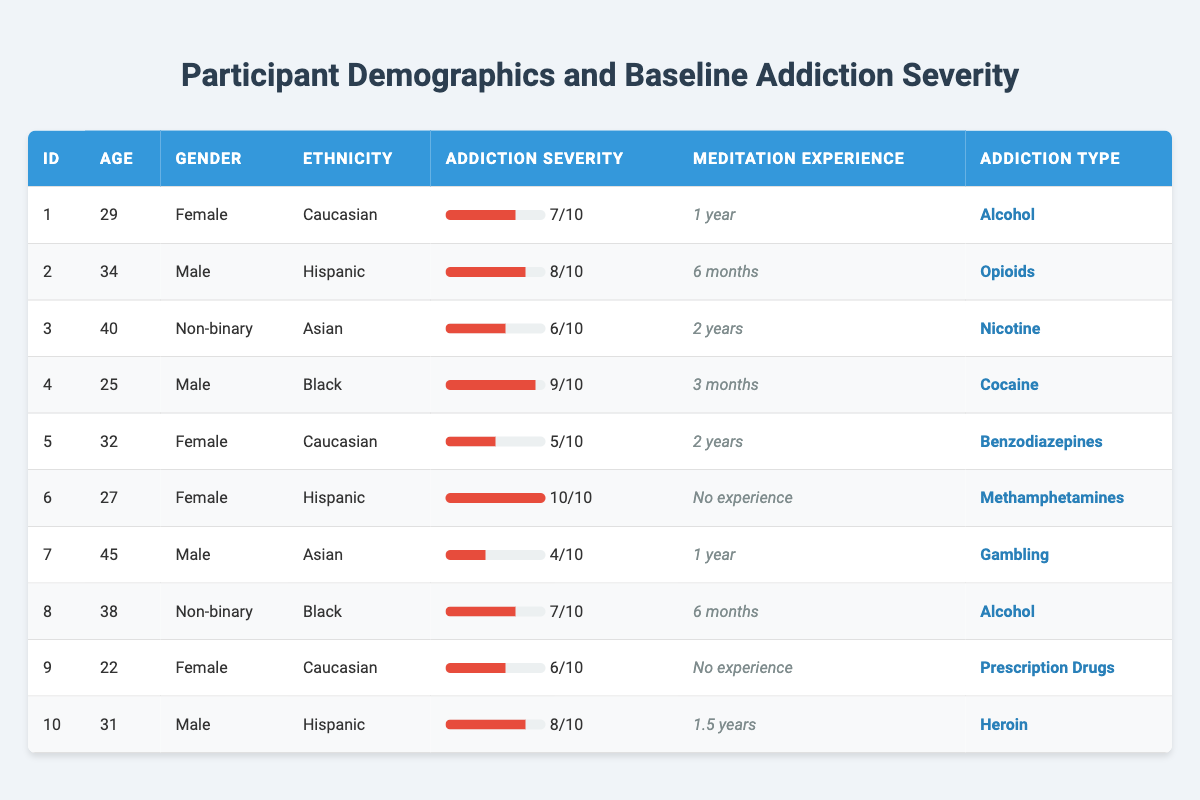What is the average age of participants in the study? The participants' ages are 29, 34, 40, 25, 32, 27, 45, 38, 22, and 31. Summing these values gives a total of 29 + 34 + 40 + 25 + 32 + 27 + 45 + 38 + 22 + 31 =  353. There are 10 participants, so the average age is 353 / 10 = 35.3.
Answer: 35.3 How many participants have prior meditation experience? Observing the meditation experience column, participants 1, 3, 5, 7, 8, and 10 have meditation experience (1 year, 2 years, 2 years, 1 year, 6 months, and 1.5 years respectively), totaling six participants.
Answer: 6 Which participant has the highest baseline addiction severity? The baseline addiction severities are 7, 8, 6, 9, 5, 10, 4, 7, 6, and 8. The maximum value among these is 10, which corresponds to participant 6 who is addicted to Methamphetamines.
Answer: Participant 6 What is the percentage of male participants in the study? There are 4 male participants (2, 4, 7, and 10) out of 10 total participants. The percentage is calculated as (4 / 10) * 100 = 40%.
Answer: 40% Is there a participant with no meditation experience who has a higher baseline addiction severity than the average of the group? The average baseline addiction severity is 7. The non-experienced participants are 6 and 9, with severities of 10 and 6, respectively. Participant 6, with a severity of 10, is above the average of 7.
Answer: Yes What is the median baseline addiction severity of participants? After sorting the baseline severities (4, 5, 6, 6, 7, 7, 8, 8, 9, 10), the median, which is the average of the two middle numbers (7 and 7), is (7 + 7) / 2 = 7.
Answer: 7 How many participants are addicted to Alcohol? Looking at the addiction types, participants 1 and 8 are both addicted to Alcohol, totaling two participants.
Answer: 2 What is the difference in baseline addiction severity between the oldest and the youngest participants? The oldest participant (45) has a severity of 4, while the youngest (22) has a severity of 6. The difference is 6 - 4 = 2.
Answer: 2 Are there more females or males with a baseline addiction severity of 8 or higher? The females with severity of 8 or higher are participant 1 (7), participant 5 (5), and participant 6 (10), while males at severity 8 or higher are participants 2 (8), 4 (9), and 10 (8). There are 1 female versus 3 males, showing more males.
Answer: Males Which type of addiction has the lowest average severity rating? The severities for each type are: Alcohol (7, 7), Opioids (8), Nicotine (6), Cocaine (9), Benzodiazepines (5), Methamphetamines (10), Gambling (4), and Prescription Drugs (6). The addiction with the lowest total is Gambling at 4.
Answer: Gambling 